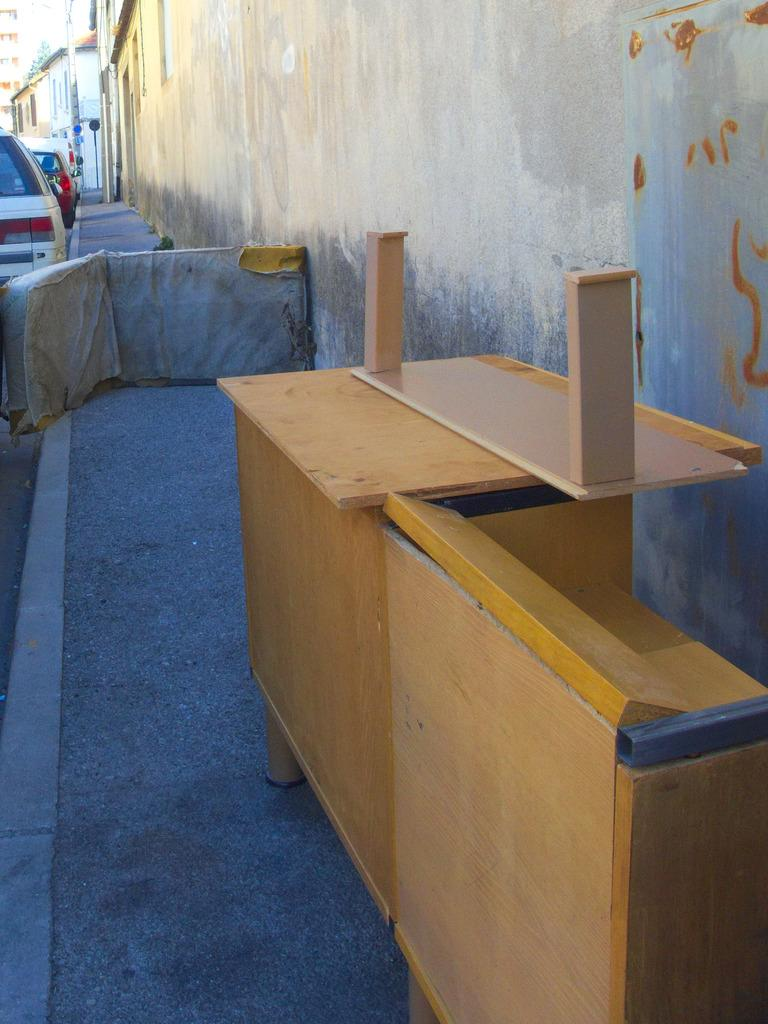What can be seen on the road in the image? There are vehicles on the road in the image. What type of furniture is visible in the image? There is a table visible in the image. What type of structures are present in the image? There are houses in the image. What type of soap is being used to wash the wrist in the image? There is no soap or wrist washing activity present in the image. What type of meal is being prepared on the table in the image? There is no meal preparation or table setting visible in the image. 